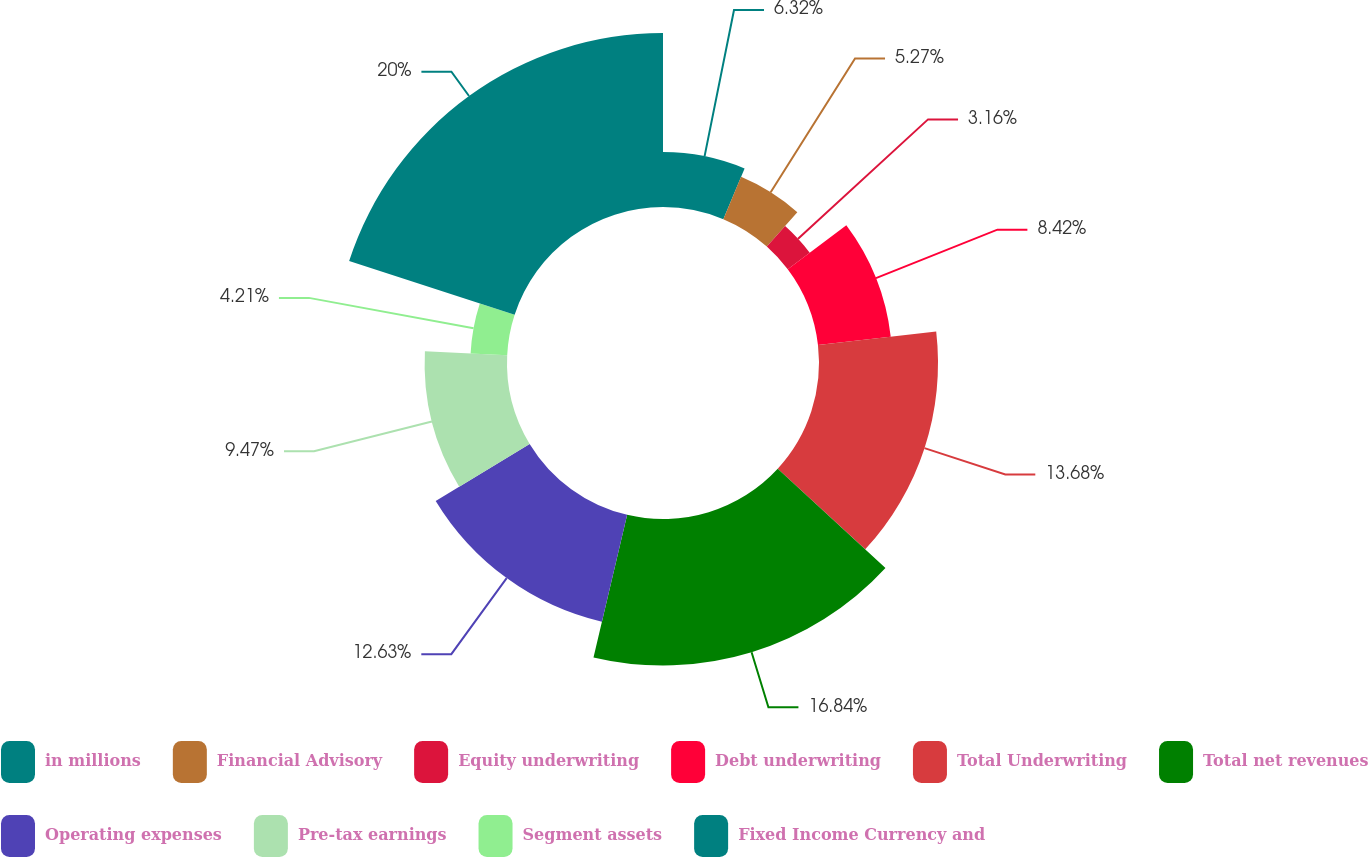Convert chart. <chart><loc_0><loc_0><loc_500><loc_500><pie_chart><fcel>in millions<fcel>Financial Advisory<fcel>Equity underwriting<fcel>Debt underwriting<fcel>Total Underwriting<fcel>Total net revenues<fcel>Operating expenses<fcel>Pre-tax earnings<fcel>Segment assets<fcel>Fixed Income Currency and<nl><fcel>6.32%<fcel>5.27%<fcel>3.16%<fcel>8.42%<fcel>13.68%<fcel>16.84%<fcel>12.63%<fcel>9.47%<fcel>4.21%<fcel>20.0%<nl></chart> 